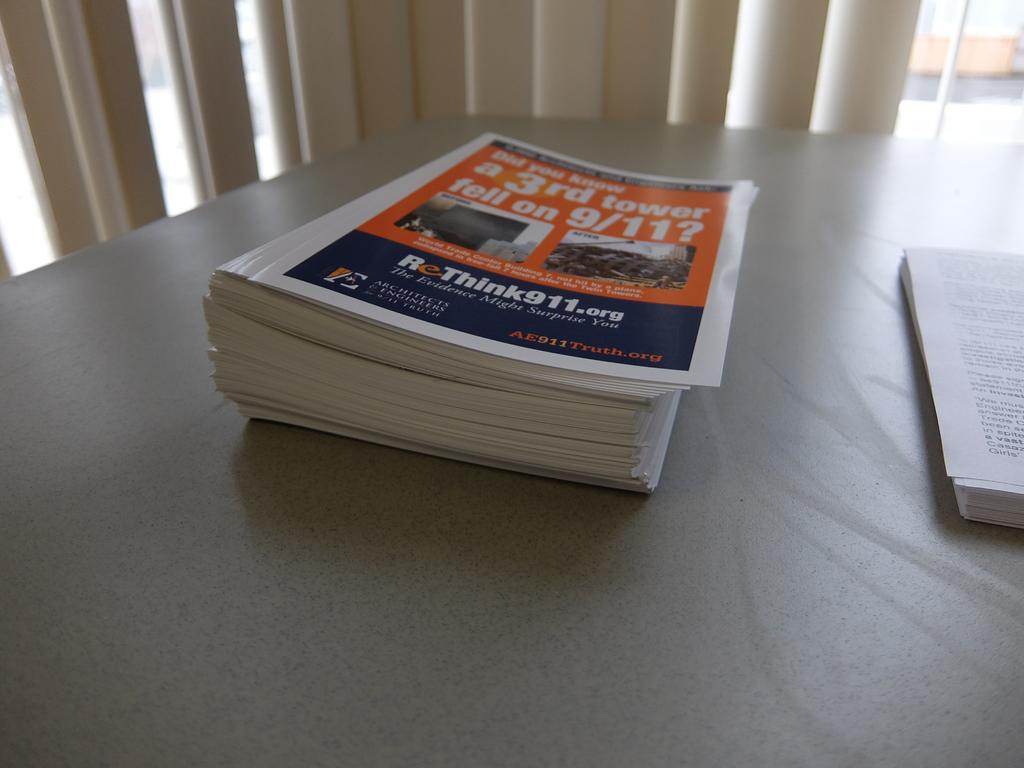Provide a one-sentence caption for the provided image. A stack of magazines on the table has 9/11 on the cover. 